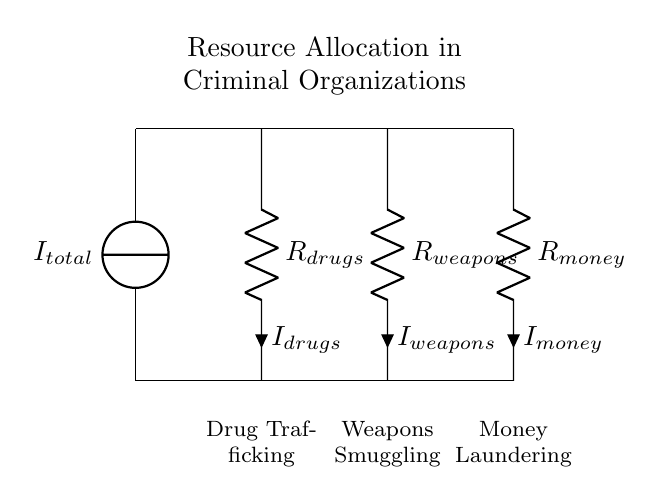What is the total current in the circuit? The total current is represented as I_total, which is the current sourced at the top of the circuit.
Answer: I_total What are the components connected in the circuit? The components are resistors labeled R_drugs, R_weapons, and R_money, representing various criminal activities.
Answer: R_drugs, R_weapons, R_money How many branches are in this current divider? There are three branches in the current divider, corresponding to the three resistors.
Answer: Three What does the resistor R_drugs represent in this circuit? R_drugs represents the resource allocation for drug trafficking in the criminal organization, as indicated by the label below the resistor.
Answer: Drug Trafficking What is the relationship between the currents through the resistors? The total current I_total is divided among the branches, where each branch current is a portion of the total based on the resistor values.
Answer: Current division Which branch has the highest allocation of resources based on standard assumptions? Typically, it could be assumed that drug trafficking would have the highest allocation, as it's often the most lucrative.
Answer: Drug Trafficking What does a higher resistor value indicate about resource allocation? A higher resistor value indicates that less current flows through that branch, suggesting lower resource allocation compared to branches with lower resistor values.
Answer: Lower resource allocation 